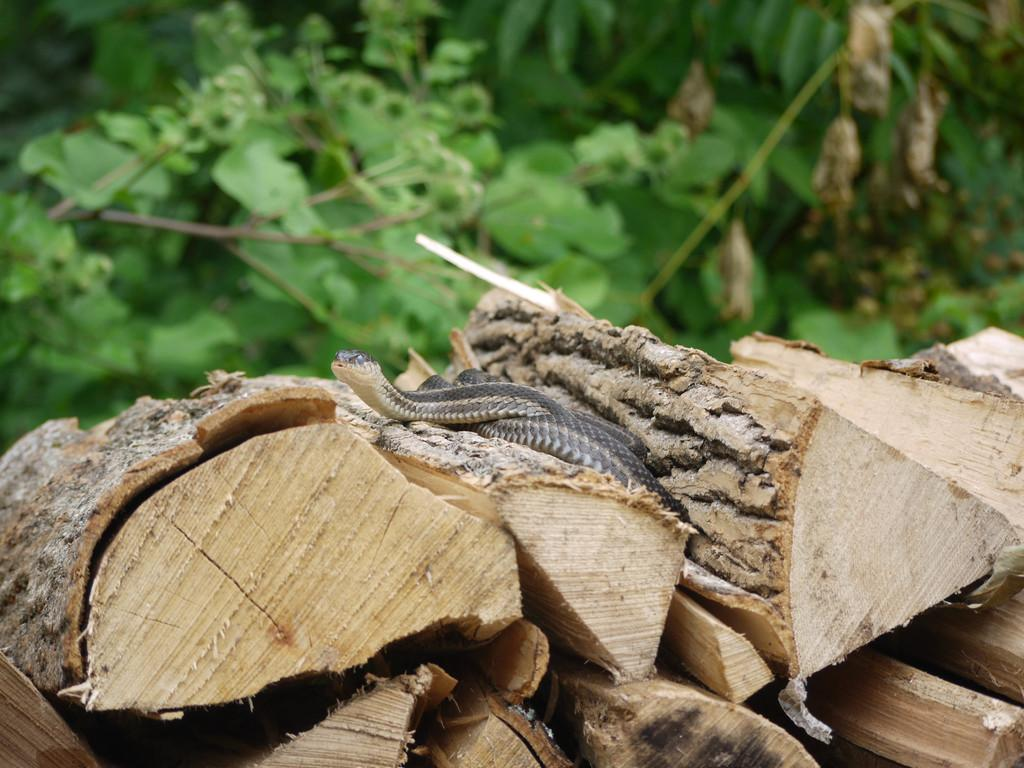What type of animal is in the image? There is a snake in the image. What material are the logs made of in the image? The logs in the image are made of wood. What can be seen in the background of the image? There are trees in the background of the image. What type of nerve can be seen in the image? There is no nerve present in the image; it features a snake and wooden logs. What type of ground is visible in the image? The ground is not visible in the image; only the snake, wooden logs, and trees are present. 